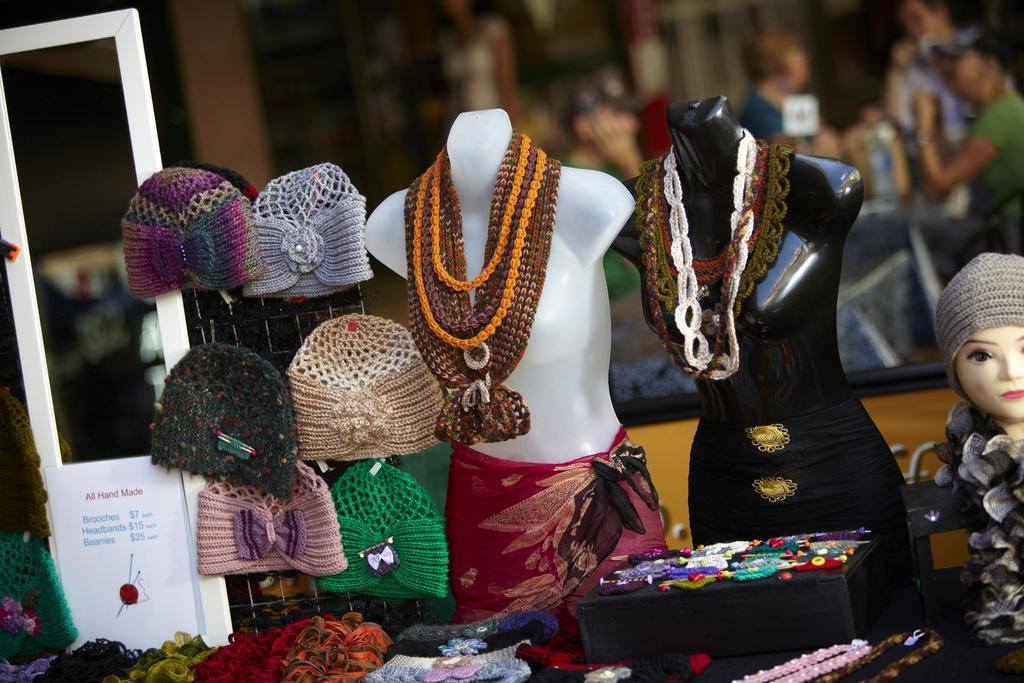What type of objects are displayed with the mannequins in the image? There are clothes, woolen jewelry, and woolen caps visible in the image. What material is used for the jewelry and caps in the image? The jewelry and caps in the image are made of wool. Can you describe the background of the image? The background of the image is blurred. Are there any other objects present in the image besides the mannequins and their accessories? Yes, there are other objects in the image. What type of tools does the carpenter use in the image? There is no carpenter present in the image, and therefore no tools can be observed. What is the expert's opinion on the quince in the image? There is no expert or quince present in the image. 